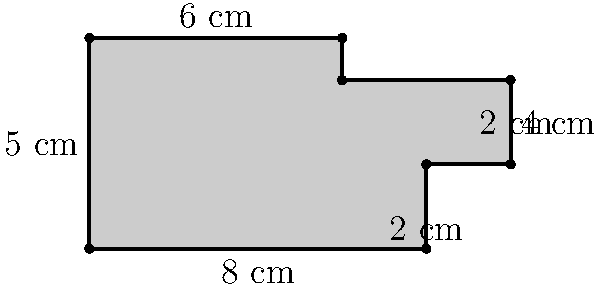You're designing a custom amplifier front panel with an irregular shape to achieve a unique look for your garage band. The dimensions of the panel are shown in the diagram. What is the perimeter of this amplifier front panel? To find the perimeter of the irregularly shaped amplifier front panel, we need to sum up all the side lengths:

1. Bottom edge: 8 cm
2. Right side (bottom part): 2 cm
3. Small step on the right: 2 cm
4. Right side (upper part): 2 cm
5. Top right edge: 4 cm
6. Top edge: 6 cm
7. Left side: 5 cm

Now, let's add all these lengths:

$$ \text{Perimeter} = 8 + 2 + 2 + 2 + 4 + 6 + 5 = 29 \text{ cm} $$

Therefore, the perimeter of the amplifier front panel is 29 cm.
Answer: 29 cm 